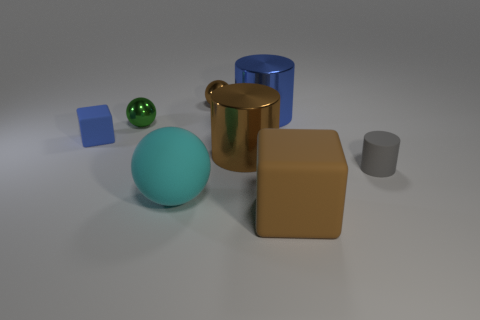Add 1 tiny green shiny spheres. How many objects exist? 9 Subtract 1 cyan balls. How many objects are left? 7 Subtract all spheres. How many objects are left? 5 Subtract all small brown balls. Subtract all small gray matte cylinders. How many objects are left? 6 Add 1 large brown shiny cylinders. How many large brown shiny cylinders are left? 2 Add 6 large cyan rubber objects. How many large cyan rubber objects exist? 7 